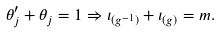<formula> <loc_0><loc_0><loc_500><loc_500>\theta ^ { \prime } _ { j } + \theta _ { j } = 1 \Rightarrow \iota _ { ( g ^ { - 1 } ) } + \iota _ { ( g ) } = m .</formula> 